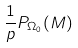<formula> <loc_0><loc_0><loc_500><loc_500>\frac { 1 } { p } P _ { \Omega _ { 0 } } ( M )</formula> 